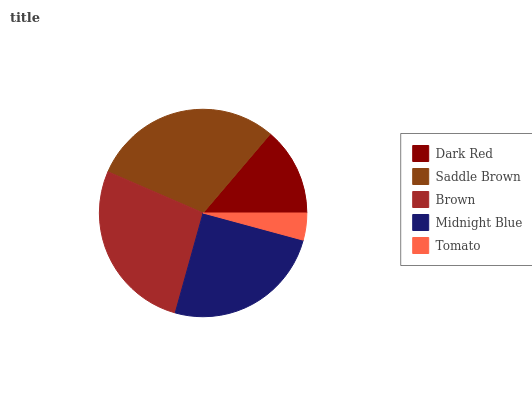Is Tomato the minimum?
Answer yes or no. Yes. Is Saddle Brown the maximum?
Answer yes or no. Yes. Is Brown the minimum?
Answer yes or no. No. Is Brown the maximum?
Answer yes or no. No. Is Saddle Brown greater than Brown?
Answer yes or no. Yes. Is Brown less than Saddle Brown?
Answer yes or no. Yes. Is Brown greater than Saddle Brown?
Answer yes or no. No. Is Saddle Brown less than Brown?
Answer yes or no. No. Is Midnight Blue the high median?
Answer yes or no. Yes. Is Midnight Blue the low median?
Answer yes or no. Yes. Is Brown the high median?
Answer yes or no. No. Is Saddle Brown the low median?
Answer yes or no. No. 